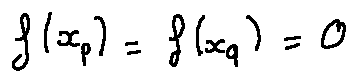Convert formula to latex. <formula><loc_0><loc_0><loc_500><loc_500>f ( x _ { p } ) = f ( x _ { q } ) = 0</formula> 